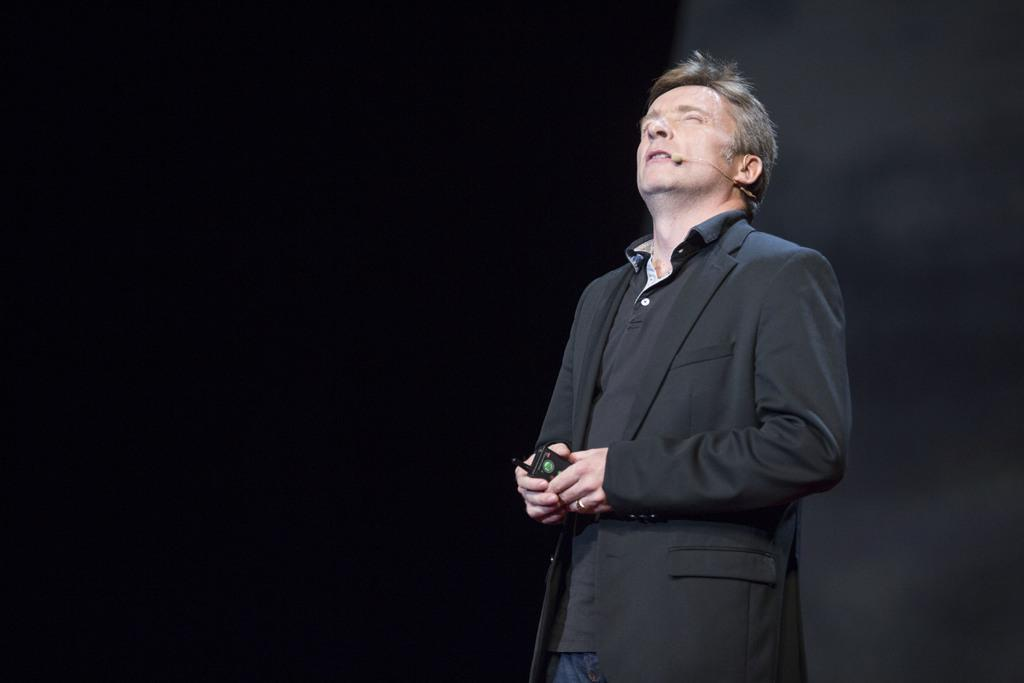What is located on the right side of the image? There is a man standing on the right side of the image. What is the man holding in the image? The man is holding an object in the image. Can you describe the man's attire in the image? The man is wearing a mic in the image. Can you tell me how many tigers are visible in the image? There are no tigers present in the image. What type of agreement is the man holding in the image? The man is not holding an agreement in the image; he is holding an unspecified object. 